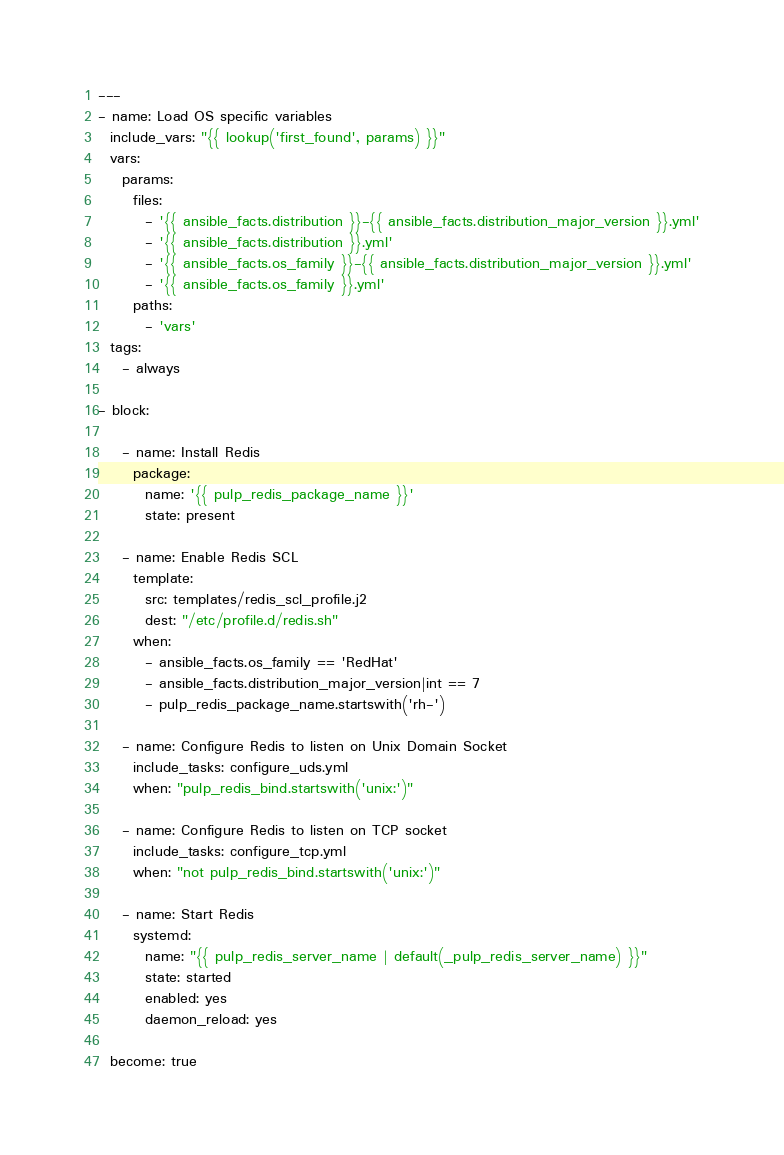Convert code to text. <code><loc_0><loc_0><loc_500><loc_500><_YAML_>---
- name: Load OS specific variables
  include_vars: "{{ lookup('first_found', params) }}"
  vars:
    params:
      files:
        - '{{ ansible_facts.distribution }}-{{ ansible_facts.distribution_major_version }}.yml'
        - '{{ ansible_facts.distribution }}.yml'
        - '{{ ansible_facts.os_family }}-{{ ansible_facts.distribution_major_version }}.yml'
        - '{{ ansible_facts.os_family }}.yml'
      paths:
        - 'vars'
  tags:
    - always

- block:

    - name: Install Redis
      package:
        name: '{{ pulp_redis_package_name }}'
        state: present

    - name: Enable Redis SCL
      template:
        src: templates/redis_scl_profile.j2
        dest: "/etc/profile.d/redis.sh"
      when:
        - ansible_facts.os_family == 'RedHat'
        - ansible_facts.distribution_major_version|int == 7
        - pulp_redis_package_name.startswith('rh-')

    - name: Configure Redis to listen on Unix Domain Socket
      include_tasks: configure_uds.yml
      when: "pulp_redis_bind.startswith('unix:')"

    - name: Configure Redis to listen on TCP socket
      include_tasks: configure_tcp.yml
      when: "not pulp_redis_bind.startswith('unix:')"

    - name: Start Redis
      systemd:
        name: "{{ pulp_redis_server_name | default(_pulp_redis_server_name) }}"
        state: started
        enabled: yes
        daemon_reload: yes

  become: true
</code> 